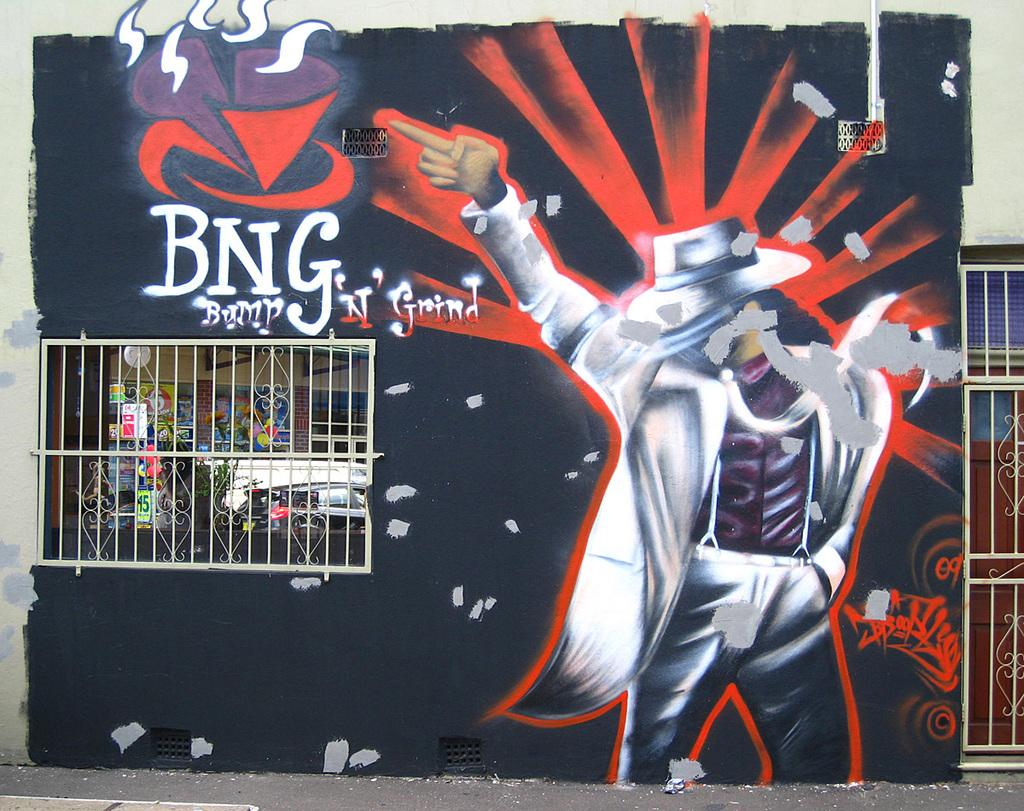<image>
Relay a brief, clear account of the picture shown. Graffiti artwork with a man in a hat for BNG Bump. 